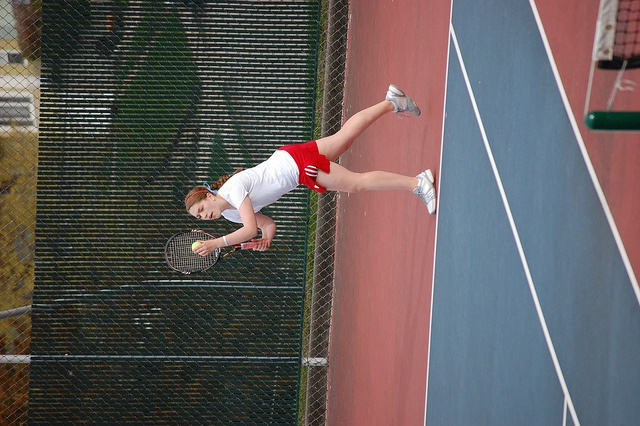Describe the objects in this image and their specific colors. I can see people in gray, tan, white, brown, and darkgray tones, tennis racket in gray, black, and darkgray tones, and sports ball in gray, khaki, and lightyellow tones in this image. 